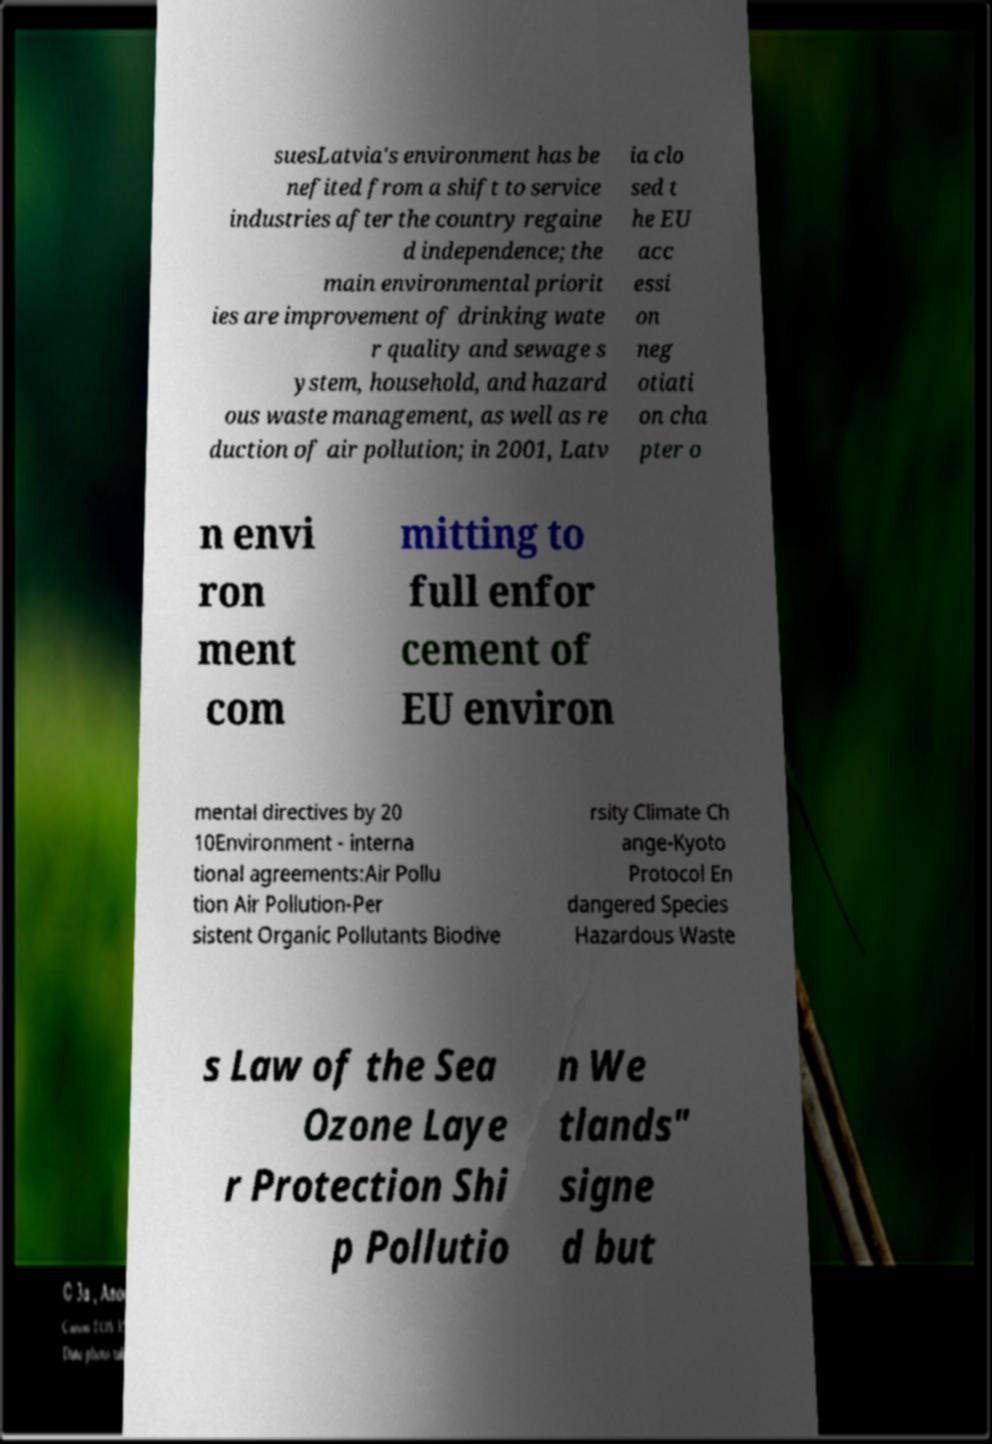For documentation purposes, I need the text within this image transcribed. Could you provide that? suesLatvia's environment has be nefited from a shift to service industries after the country regaine d independence; the main environmental priorit ies are improvement of drinking wate r quality and sewage s ystem, household, and hazard ous waste management, as well as re duction of air pollution; in 2001, Latv ia clo sed t he EU acc essi on neg otiati on cha pter o n envi ron ment com mitting to full enfor cement of EU environ mental directives by 20 10Environment - interna tional agreements:Air Pollu tion Air Pollution-Per sistent Organic Pollutants Biodive rsity Climate Ch ange-Kyoto Protocol En dangered Species Hazardous Waste s Law of the Sea Ozone Laye r Protection Shi p Pollutio n We tlands" signe d but 